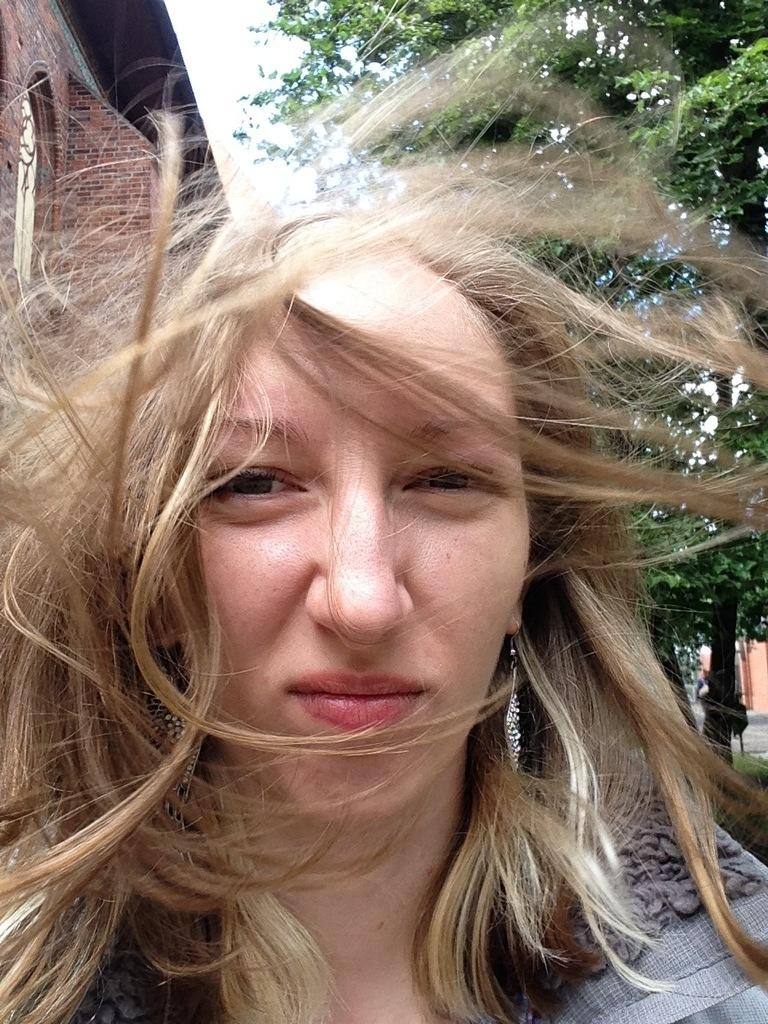Who is the main subject in the image? There is a woman in the image. How is the woman's hair styled? The woman's hair is in a zigzag position. What type of vegetation can be seen on the right side of the image? There is a green tree on the right side of the image. What type of structure is on the left side of the image? There is a building on the left side of the image. What type of credit can be seen on the woman's clothing in the image? There is no credit visible on the woman's clothing in the image. What type of destruction can be seen in the image? There is no destruction present in the image; it appears to be a peaceful scene with a woman, a tree, and a building. 